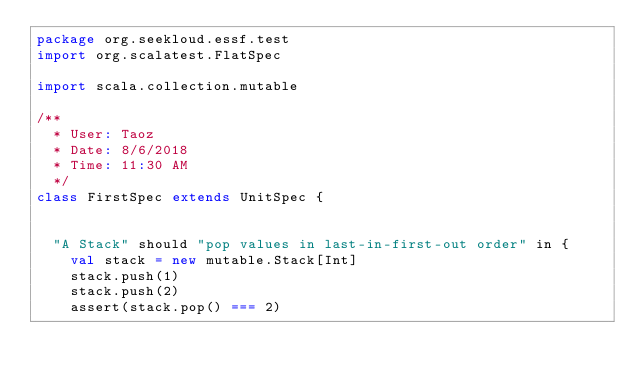<code> <loc_0><loc_0><loc_500><loc_500><_Scala_>package org.seekloud.essf.test
import org.scalatest.FlatSpec

import scala.collection.mutable

/**
  * User: Taoz
  * Date: 8/6/2018
  * Time: 11:30 AM
  */
class FirstSpec extends UnitSpec {


  "A Stack" should "pop values in last-in-first-out order" in {
    val stack = new mutable.Stack[Int]
    stack.push(1)
    stack.push(2)
    assert(stack.pop() === 2)</code> 